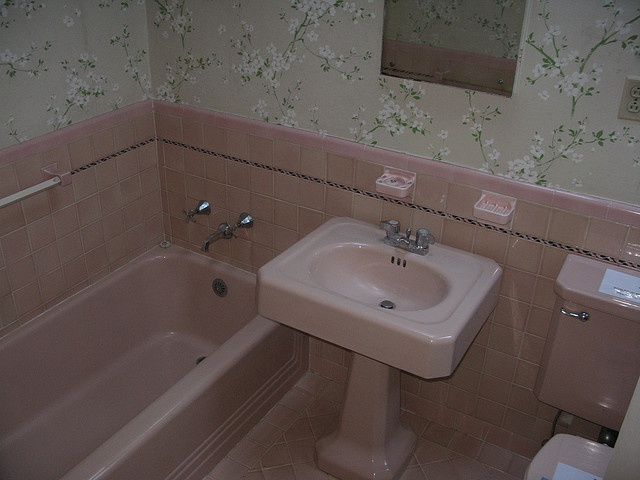Describe the objects in this image and their specific colors. I can see sink in gray tones and toilet in gray, black, maroon, and darkgray tones in this image. 